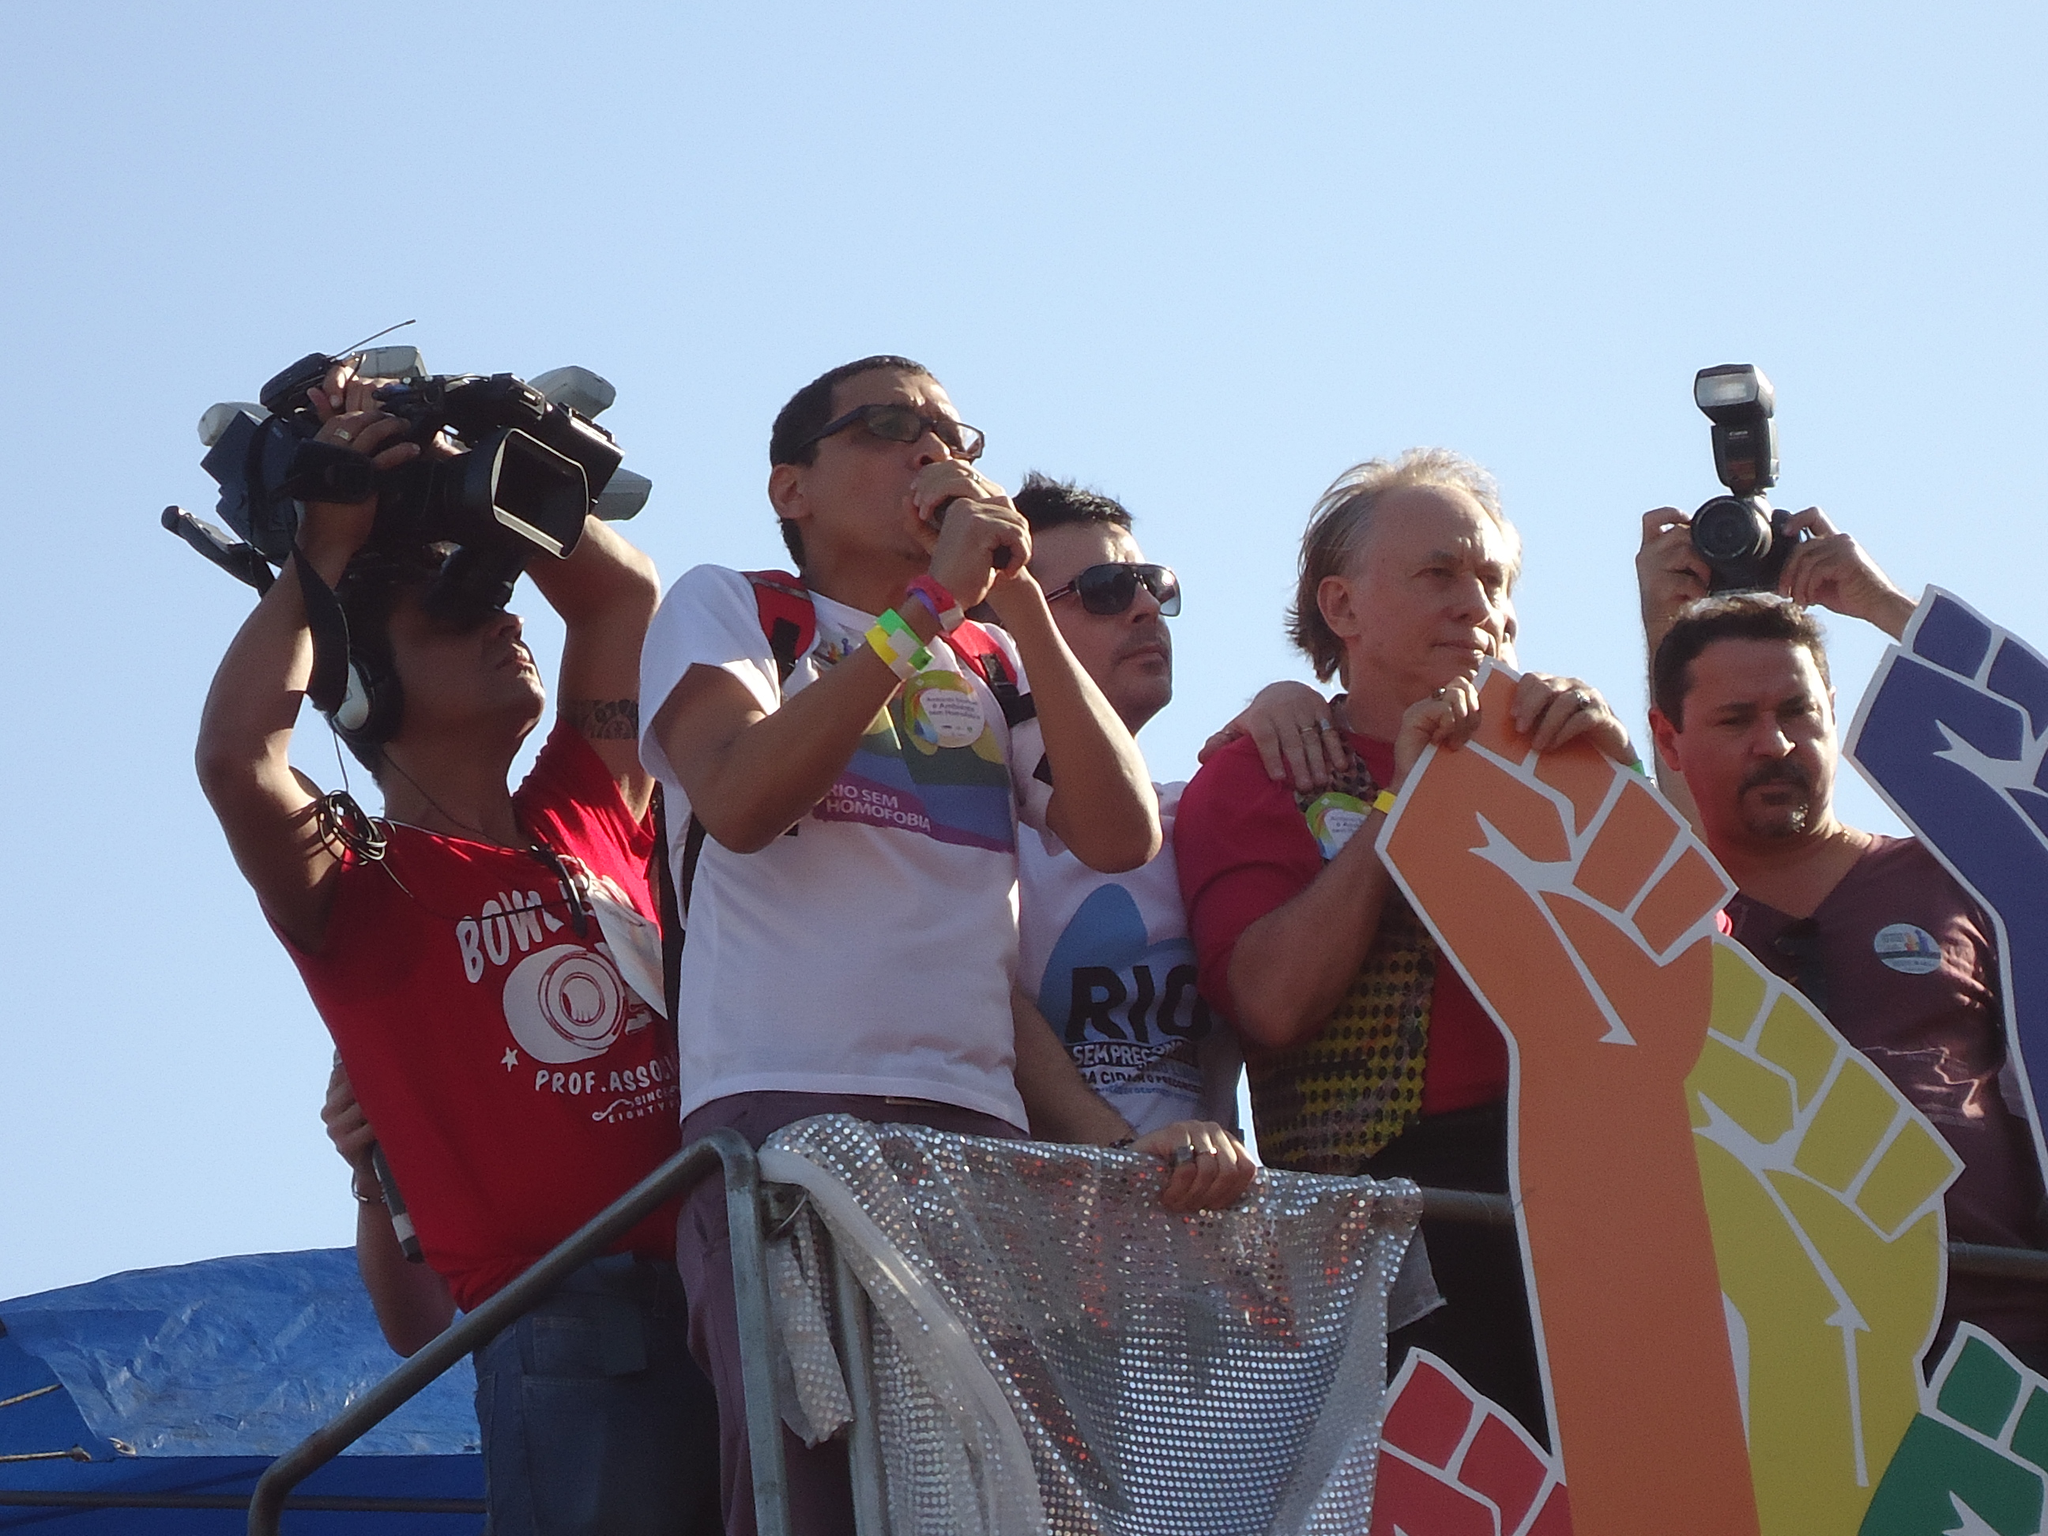Describe this image in one or two sentences. In this image we can see group of people standing. One person is wearing spectacles and holding microphone in his hand. One person is holding a camera in his hand. In the background we can see cloth a blue cover and sky. 